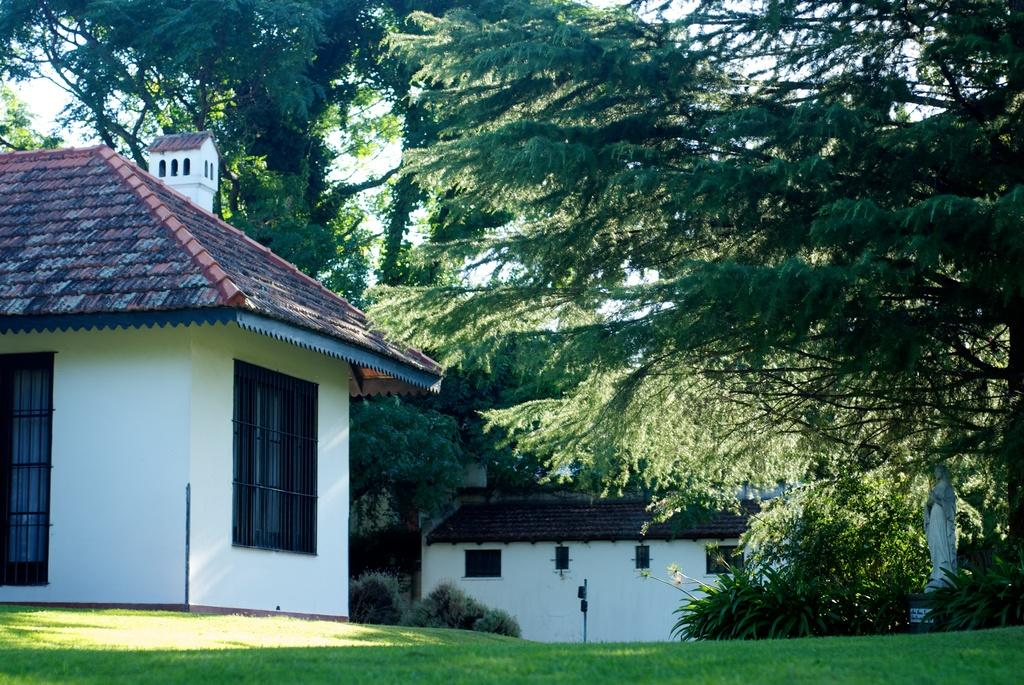What type of vegetation is present in the image? There is grass in the image. What type of structures can be seen in the image? There are houses in the image. What can be seen in the background of the image? There are trees and the sky in the background of the image. How would you describe the sky in the image? The sky is clear and visible in the background of the image. What type of chairs are present in the image? There are no chairs visible in the image. What time of day is it in the image? The time of day cannot be determined from the image, as there is no specific indication of morning or any other time. 